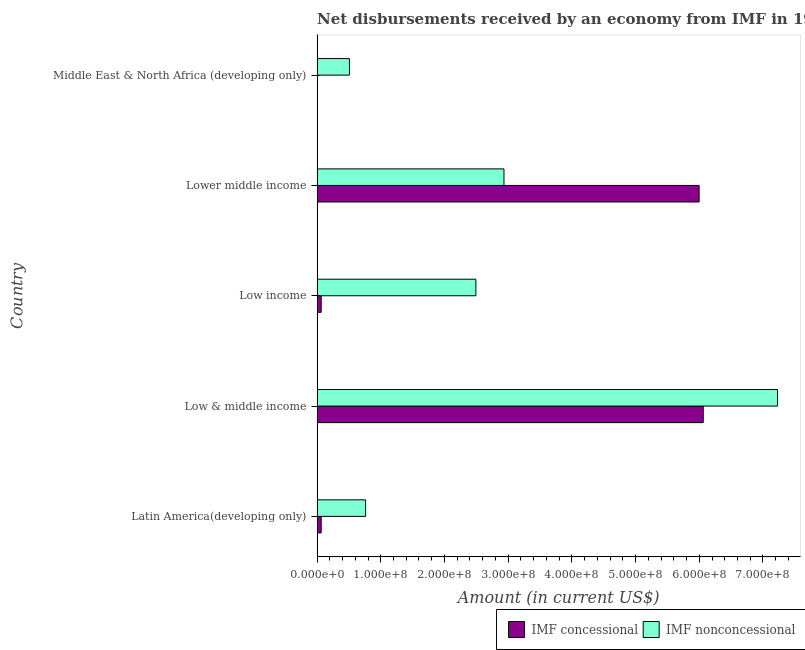How many bars are there on the 3rd tick from the bottom?
Make the answer very short. 2. What is the label of the 1st group of bars from the top?
Provide a succinct answer. Middle East & North Africa (developing only). What is the net concessional disbursements from imf in Low & middle income?
Your answer should be very brief. 6.06e+08. Across all countries, what is the maximum net concessional disbursements from imf?
Ensure brevity in your answer.  6.06e+08. Across all countries, what is the minimum net non concessional disbursements from imf?
Your response must be concise. 5.08e+07. In which country was the net non concessional disbursements from imf maximum?
Your response must be concise. Low & middle income. What is the total net concessional disbursements from imf in the graph?
Your answer should be very brief. 1.22e+09. What is the difference between the net non concessional disbursements from imf in Low & middle income and that in Middle East & North Africa (developing only)?
Give a very brief answer. 6.72e+08. What is the difference between the net non concessional disbursements from imf in Low & middle income and the net concessional disbursements from imf in Lower middle income?
Ensure brevity in your answer.  1.23e+08. What is the average net non concessional disbursements from imf per country?
Your answer should be very brief. 2.79e+08. What is the difference between the net concessional disbursements from imf and net non concessional disbursements from imf in Lower middle income?
Your answer should be compact. 3.06e+08. In how many countries, is the net concessional disbursements from imf greater than 280000000 US$?
Give a very brief answer. 2. What is the ratio of the net non concessional disbursements from imf in Latin America(developing only) to that in Low income?
Provide a short and direct response. 0.3. Is the net non concessional disbursements from imf in Low income less than that in Lower middle income?
Your answer should be very brief. Yes. What is the difference between the highest and the second highest net concessional disbursements from imf?
Give a very brief answer. 6.50e+06. What is the difference between the highest and the lowest net concessional disbursements from imf?
Your answer should be very brief. 6.06e+08. In how many countries, is the net concessional disbursements from imf greater than the average net concessional disbursements from imf taken over all countries?
Your response must be concise. 2. How many bars are there?
Your answer should be very brief. 9. Are the values on the major ticks of X-axis written in scientific E-notation?
Provide a short and direct response. Yes. Does the graph contain grids?
Provide a short and direct response. No. What is the title of the graph?
Your response must be concise. Net disbursements received by an economy from IMF in 1974. Does "Subsidies" appear as one of the legend labels in the graph?
Ensure brevity in your answer.  No. What is the Amount (in current US$) of IMF concessional in Latin America(developing only)?
Provide a short and direct response. 6.50e+06. What is the Amount (in current US$) of IMF nonconcessional in Latin America(developing only)?
Provide a short and direct response. 7.62e+07. What is the Amount (in current US$) in IMF concessional in Low & middle income?
Your answer should be very brief. 6.06e+08. What is the Amount (in current US$) in IMF nonconcessional in Low & middle income?
Your response must be concise. 7.23e+08. What is the Amount (in current US$) of IMF concessional in Low income?
Provide a succinct answer. 6.50e+06. What is the Amount (in current US$) in IMF nonconcessional in Low income?
Your response must be concise. 2.49e+08. What is the Amount (in current US$) of IMF concessional in Lower middle income?
Make the answer very short. 6.00e+08. What is the Amount (in current US$) in IMF nonconcessional in Lower middle income?
Ensure brevity in your answer.  2.93e+08. What is the Amount (in current US$) in IMF nonconcessional in Middle East & North Africa (developing only)?
Your answer should be very brief. 5.08e+07. Across all countries, what is the maximum Amount (in current US$) in IMF concessional?
Keep it short and to the point. 6.06e+08. Across all countries, what is the maximum Amount (in current US$) in IMF nonconcessional?
Make the answer very short. 7.23e+08. Across all countries, what is the minimum Amount (in current US$) of IMF concessional?
Your answer should be very brief. 0. Across all countries, what is the minimum Amount (in current US$) in IMF nonconcessional?
Provide a short and direct response. 5.08e+07. What is the total Amount (in current US$) in IMF concessional in the graph?
Your answer should be very brief. 1.22e+09. What is the total Amount (in current US$) of IMF nonconcessional in the graph?
Provide a succinct answer. 1.39e+09. What is the difference between the Amount (in current US$) in IMF concessional in Latin America(developing only) and that in Low & middle income?
Make the answer very short. -6.00e+08. What is the difference between the Amount (in current US$) in IMF nonconcessional in Latin America(developing only) and that in Low & middle income?
Offer a terse response. -6.47e+08. What is the difference between the Amount (in current US$) in IMF nonconcessional in Latin America(developing only) and that in Low income?
Provide a succinct answer. -1.73e+08. What is the difference between the Amount (in current US$) in IMF concessional in Latin America(developing only) and that in Lower middle income?
Offer a very short reply. -5.93e+08. What is the difference between the Amount (in current US$) in IMF nonconcessional in Latin America(developing only) and that in Lower middle income?
Make the answer very short. -2.17e+08. What is the difference between the Amount (in current US$) in IMF nonconcessional in Latin America(developing only) and that in Middle East & North Africa (developing only)?
Your answer should be compact. 2.53e+07. What is the difference between the Amount (in current US$) in IMF concessional in Low & middle income and that in Low income?
Give a very brief answer. 6.00e+08. What is the difference between the Amount (in current US$) of IMF nonconcessional in Low & middle income and that in Low income?
Keep it short and to the point. 4.73e+08. What is the difference between the Amount (in current US$) of IMF concessional in Low & middle income and that in Lower middle income?
Provide a succinct answer. 6.50e+06. What is the difference between the Amount (in current US$) of IMF nonconcessional in Low & middle income and that in Lower middle income?
Offer a very short reply. 4.29e+08. What is the difference between the Amount (in current US$) of IMF nonconcessional in Low & middle income and that in Middle East & North Africa (developing only)?
Make the answer very short. 6.72e+08. What is the difference between the Amount (in current US$) of IMF concessional in Low income and that in Lower middle income?
Your response must be concise. -5.93e+08. What is the difference between the Amount (in current US$) in IMF nonconcessional in Low income and that in Lower middle income?
Make the answer very short. -4.41e+07. What is the difference between the Amount (in current US$) in IMF nonconcessional in Low income and that in Middle East & North Africa (developing only)?
Make the answer very short. 1.99e+08. What is the difference between the Amount (in current US$) of IMF nonconcessional in Lower middle income and that in Middle East & North Africa (developing only)?
Ensure brevity in your answer.  2.43e+08. What is the difference between the Amount (in current US$) of IMF concessional in Latin America(developing only) and the Amount (in current US$) of IMF nonconcessional in Low & middle income?
Give a very brief answer. -7.16e+08. What is the difference between the Amount (in current US$) of IMF concessional in Latin America(developing only) and the Amount (in current US$) of IMF nonconcessional in Low income?
Offer a terse response. -2.43e+08. What is the difference between the Amount (in current US$) in IMF concessional in Latin America(developing only) and the Amount (in current US$) in IMF nonconcessional in Lower middle income?
Ensure brevity in your answer.  -2.87e+08. What is the difference between the Amount (in current US$) of IMF concessional in Latin America(developing only) and the Amount (in current US$) of IMF nonconcessional in Middle East & North Africa (developing only)?
Make the answer very short. -4.43e+07. What is the difference between the Amount (in current US$) of IMF concessional in Low & middle income and the Amount (in current US$) of IMF nonconcessional in Low income?
Provide a succinct answer. 3.57e+08. What is the difference between the Amount (in current US$) of IMF concessional in Low & middle income and the Amount (in current US$) of IMF nonconcessional in Lower middle income?
Give a very brief answer. 3.13e+08. What is the difference between the Amount (in current US$) in IMF concessional in Low & middle income and the Amount (in current US$) in IMF nonconcessional in Middle East & North Africa (developing only)?
Provide a succinct answer. 5.55e+08. What is the difference between the Amount (in current US$) of IMF concessional in Low income and the Amount (in current US$) of IMF nonconcessional in Lower middle income?
Offer a very short reply. -2.87e+08. What is the difference between the Amount (in current US$) of IMF concessional in Low income and the Amount (in current US$) of IMF nonconcessional in Middle East & North Africa (developing only)?
Give a very brief answer. -4.43e+07. What is the difference between the Amount (in current US$) of IMF concessional in Lower middle income and the Amount (in current US$) of IMF nonconcessional in Middle East & North Africa (developing only)?
Keep it short and to the point. 5.49e+08. What is the average Amount (in current US$) of IMF concessional per country?
Provide a succinct answer. 2.44e+08. What is the average Amount (in current US$) of IMF nonconcessional per country?
Offer a terse response. 2.79e+08. What is the difference between the Amount (in current US$) of IMF concessional and Amount (in current US$) of IMF nonconcessional in Latin America(developing only)?
Offer a very short reply. -6.97e+07. What is the difference between the Amount (in current US$) of IMF concessional and Amount (in current US$) of IMF nonconcessional in Low & middle income?
Keep it short and to the point. -1.17e+08. What is the difference between the Amount (in current US$) in IMF concessional and Amount (in current US$) in IMF nonconcessional in Low income?
Offer a terse response. -2.43e+08. What is the difference between the Amount (in current US$) in IMF concessional and Amount (in current US$) in IMF nonconcessional in Lower middle income?
Your answer should be compact. 3.06e+08. What is the ratio of the Amount (in current US$) in IMF concessional in Latin America(developing only) to that in Low & middle income?
Offer a terse response. 0.01. What is the ratio of the Amount (in current US$) in IMF nonconcessional in Latin America(developing only) to that in Low & middle income?
Offer a very short reply. 0.11. What is the ratio of the Amount (in current US$) of IMF concessional in Latin America(developing only) to that in Low income?
Your response must be concise. 1. What is the ratio of the Amount (in current US$) of IMF nonconcessional in Latin America(developing only) to that in Low income?
Your answer should be very brief. 0.31. What is the ratio of the Amount (in current US$) of IMF concessional in Latin America(developing only) to that in Lower middle income?
Your response must be concise. 0.01. What is the ratio of the Amount (in current US$) of IMF nonconcessional in Latin America(developing only) to that in Lower middle income?
Offer a very short reply. 0.26. What is the ratio of the Amount (in current US$) in IMF nonconcessional in Latin America(developing only) to that in Middle East & North Africa (developing only)?
Ensure brevity in your answer.  1.5. What is the ratio of the Amount (in current US$) of IMF concessional in Low & middle income to that in Low income?
Make the answer very short. 93.27. What is the ratio of the Amount (in current US$) in IMF nonconcessional in Low & middle income to that in Low income?
Make the answer very short. 2.9. What is the ratio of the Amount (in current US$) in IMF concessional in Low & middle income to that in Lower middle income?
Your answer should be compact. 1.01. What is the ratio of the Amount (in current US$) of IMF nonconcessional in Low & middle income to that in Lower middle income?
Your answer should be compact. 2.46. What is the ratio of the Amount (in current US$) of IMF nonconcessional in Low & middle income to that in Middle East & North Africa (developing only)?
Ensure brevity in your answer.  14.22. What is the ratio of the Amount (in current US$) of IMF concessional in Low income to that in Lower middle income?
Provide a succinct answer. 0.01. What is the ratio of the Amount (in current US$) of IMF nonconcessional in Low income to that in Lower middle income?
Provide a succinct answer. 0.85. What is the ratio of the Amount (in current US$) of IMF nonconcessional in Low income to that in Middle East & North Africa (developing only)?
Provide a succinct answer. 4.91. What is the ratio of the Amount (in current US$) of IMF nonconcessional in Lower middle income to that in Middle East & North Africa (developing only)?
Your response must be concise. 5.77. What is the difference between the highest and the second highest Amount (in current US$) in IMF concessional?
Offer a very short reply. 6.50e+06. What is the difference between the highest and the second highest Amount (in current US$) in IMF nonconcessional?
Give a very brief answer. 4.29e+08. What is the difference between the highest and the lowest Amount (in current US$) of IMF concessional?
Ensure brevity in your answer.  6.06e+08. What is the difference between the highest and the lowest Amount (in current US$) in IMF nonconcessional?
Your response must be concise. 6.72e+08. 